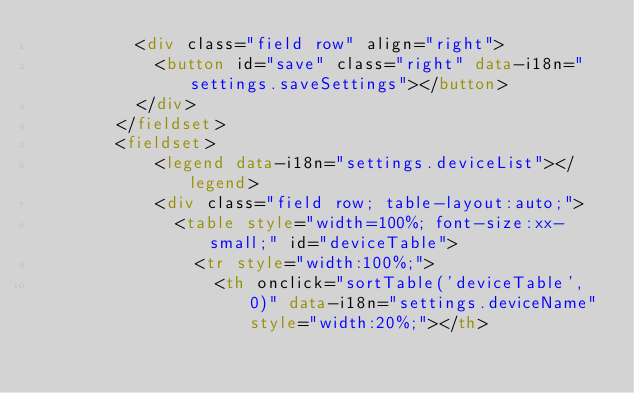<code> <loc_0><loc_0><loc_500><loc_500><_HTML_>          <div class="field row" align="right">
            <button id="save" class="right" data-i18n="settings.saveSettings"></button>
          </div>
        </fieldset>
        <fieldset>
            <legend data-i18n="settings.deviceList"></legend>
            <div class="field row; table-layout:auto;">
              <table style="width=100%; font-size:xx-small;" id="deviceTable">
                <tr style="width:100%;">
                  <th onclick="sortTable('deviceTable', 0)" data-i18n="settings.deviceName" style="width:20%;"></th></code> 